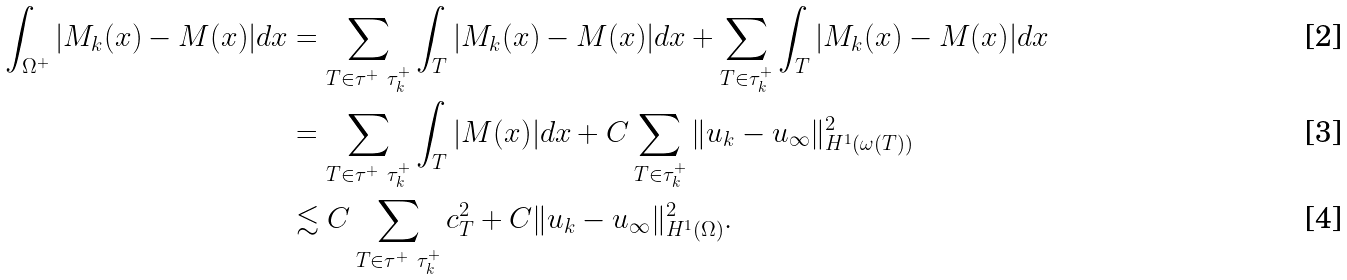<formula> <loc_0><loc_0><loc_500><loc_500>\int _ { \Omega ^ { + } } | M _ { k } ( x ) - M ( x ) | d x & = \sum _ { T \in \tau ^ { + } \ \tau ^ { + } _ { k } } \int _ { T } | M _ { k } ( x ) - M ( x ) | d x + \sum _ { T \in \tau ^ { + } _ { k } } \int _ { T } | M _ { k } ( x ) - M ( x ) | d x \\ & = \sum _ { T \in \tau ^ { + } \ \tau ^ { + } _ { k } } \int _ { T } | M ( x ) | d x + C \sum _ { T \in \tau ^ { + } _ { k } } \| u _ { k } - u _ { \infty } \| _ { H ^ { 1 } ( \omega ( T ) ) } ^ { 2 } \\ & \lesssim C \sum _ { T \in \tau ^ { + } \ \tau ^ { + } _ { k } } c _ { T } ^ { 2 } + C \| u _ { k } - u _ { \infty } \| _ { H ^ { 1 } ( \Omega ) } ^ { 2 } .</formula> 